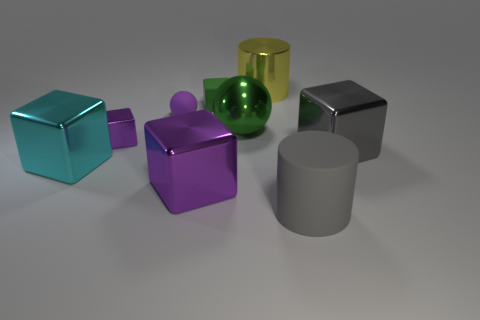Subtract 1 blocks. How many blocks are left? 4 Subtract all green blocks. How many blocks are left? 4 Subtract all cyan cubes. How many cubes are left? 4 Add 1 metal cylinders. How many objects exist? 10 Subtract all red blocks. Subtract all cyan cylinders. How many blocks are left? 5 Subtract all balls. How many objects are left? 7 Add 3 gray cylinders. How many gray cylinders exist? 4 Subtract 1 green spheres. How many objects are left? 8 Subtract all cyan spheres. Subtract all tiny purple balls. How many objects are left? 8 Add 4 cyan blocks. How many cyan blocks are left? 5 